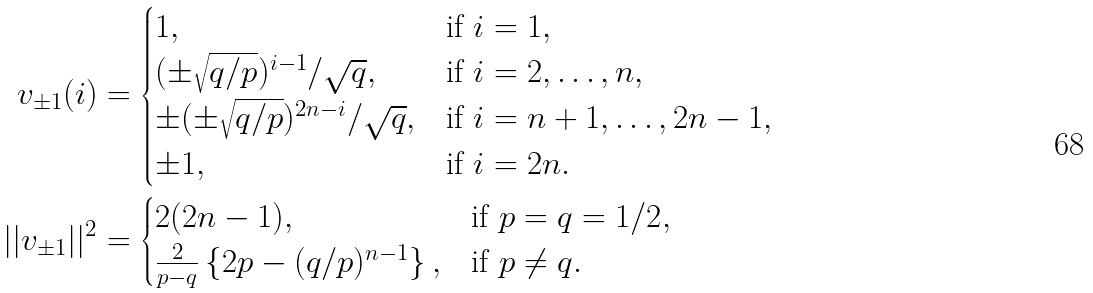Convert formula to latex. <formula><loc_0><loc_0><loc_500><loc_500>v _ { \pm 1 } ( i ) & = \begin{cases} 1 , & \text {if $i=1$} , \\ ( \pm \sqrt { q / p } ) ^ { i - 1 } / \sqrt { q } , & \text {if $i=2,\dots,n$} , \\ \pm ( \pm \sqrt { q / p } ) ^ { 2 n - i } / \sqrt { q } , & \text {if $i=n+1,\dots,2n-1$} , \\ \pm 1 , & \text {if $i=2n$} . \\ \end{cases} \\ | | v _ { \pm 1 } | | ^ { 2 } & = \begin{cases} 2 ( 2 n - 1 ) , & \text {if $p=q=1/2$} , \\ \frac { 2 } { p - q } \left \{ 2 p - ( q / p ) ^ { n - 1 } \right \} , & \text {if $p\neq q$} . \\ \end{cases}</formula> 